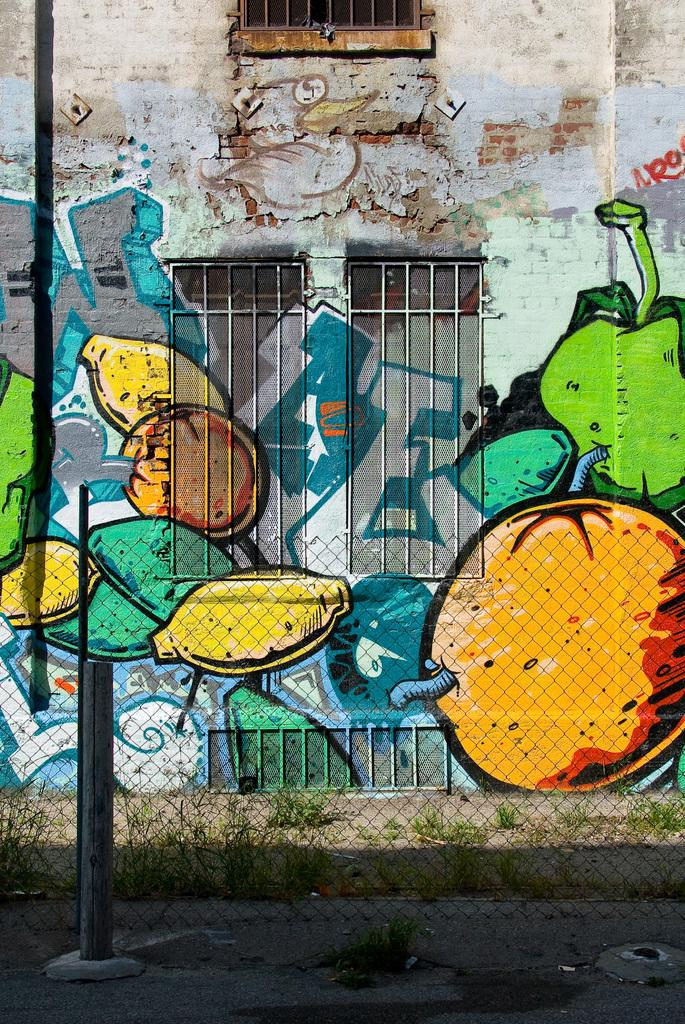What can be seen at the front of the image? There are two poles in the front of the image. What is visible in the background of the image? There is an iron fence, grass, a building, windows, and different types of paintings on the wall in the background of the image. What type of cord is being used to power the paintings on the wall in the image? There is no cord visible in the image, and the paintings on the wall are not powered by any visible source. What type of current can be seen flowing through the grass in the image? There is no current visible in the image, and the grass is not depicted as being electrified or carrying any current. 